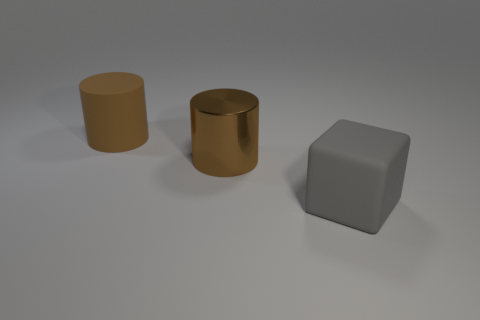What material is the large object that is the same color as the rubber cylinder?
Offer a terse response. Metal. Is there anything else that has the same shape as the big brown rubber object?
Ensure brevity in your answer.  Yes. Is the shiny cylinder the same size as the brown rubber cylinder?
Offer a very short reply. Yes. There is a big brown object that is in front of the rubber object that is behind the big gray matte cube that is in front of the brown metal thing; what is its material?
Make the answer very short. Metal. Are there the same number of gray things that are right of the matte cube and brown matte cylinders?
Make the answer very short. No. Is there anything else that has the same size as the gray cube?
Keep it short and to the point. Yes. What number of things are either brown rubber cylinders or large metal objects?
Make the answer very short. 2. There is a thing that is the same material as the big gray cube; what shape is it?
Offer a terse response. Cylinder. What is the size of the cylinder right of the matte thing that is to the left of the gray cube?
Offer a very short reply. Large. What number of tiny objects are gray objects or brown metal cylinders?
Offer a terse response. 0. 